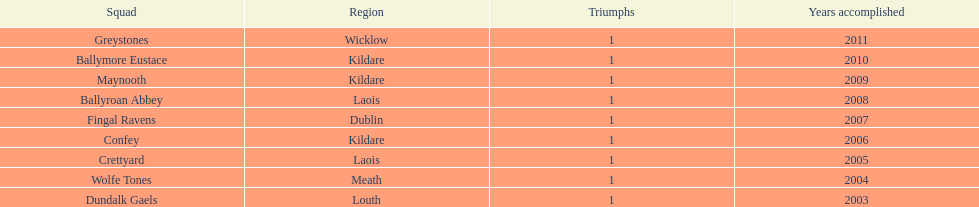What is the difference years won for crettyard and greystones 6. 